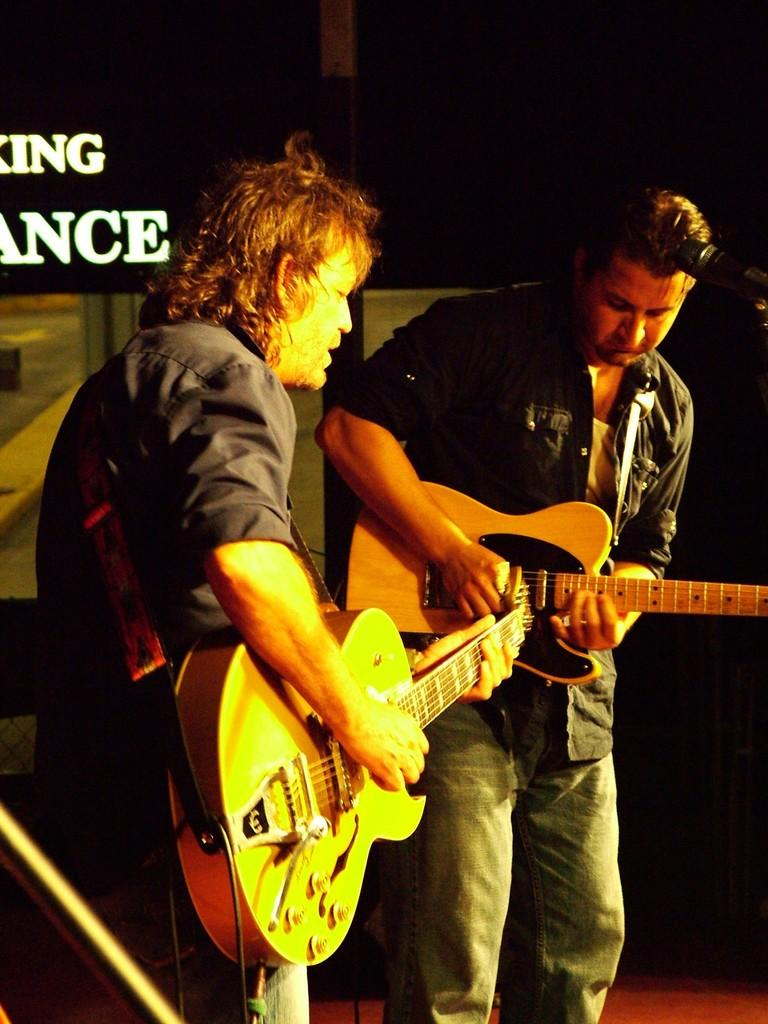How many people are in the image? There are two guys in the image. What are the guys holding in the image? The guys are holding a guitar. What are the guys doing with the guitar? The guys are playing the guitar. What type of line or channel can be seen in the image? There is no line or channel present in the image; it features two guys playing a guitar. What rhythm is the guitar playing in the image? The image does not provide information about the rhythm of the guitar playing, as it only shows the guys holding and playing the guitar. 